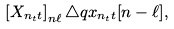<formula> <loc_0><loc_0><loc_500><loc_500>\left [ X _ { n _ { t } t } \right ] _ { n \ell } \triangle q x _ { n _ { t } t } [ n - \ell ] ,</formula> 